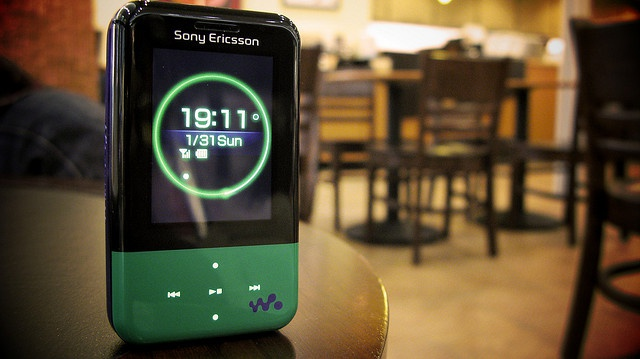Describe the objects in this image and their specific colors. I can see cell phone in maroon, black, darkgreen, and gray tones, dining table in maroon, black, darkgreen, and gray tones, chair in maroon, black, and brown tones, chair in maroon, black, and olive tones, and people in maroon, black, and gray tones in this image. 